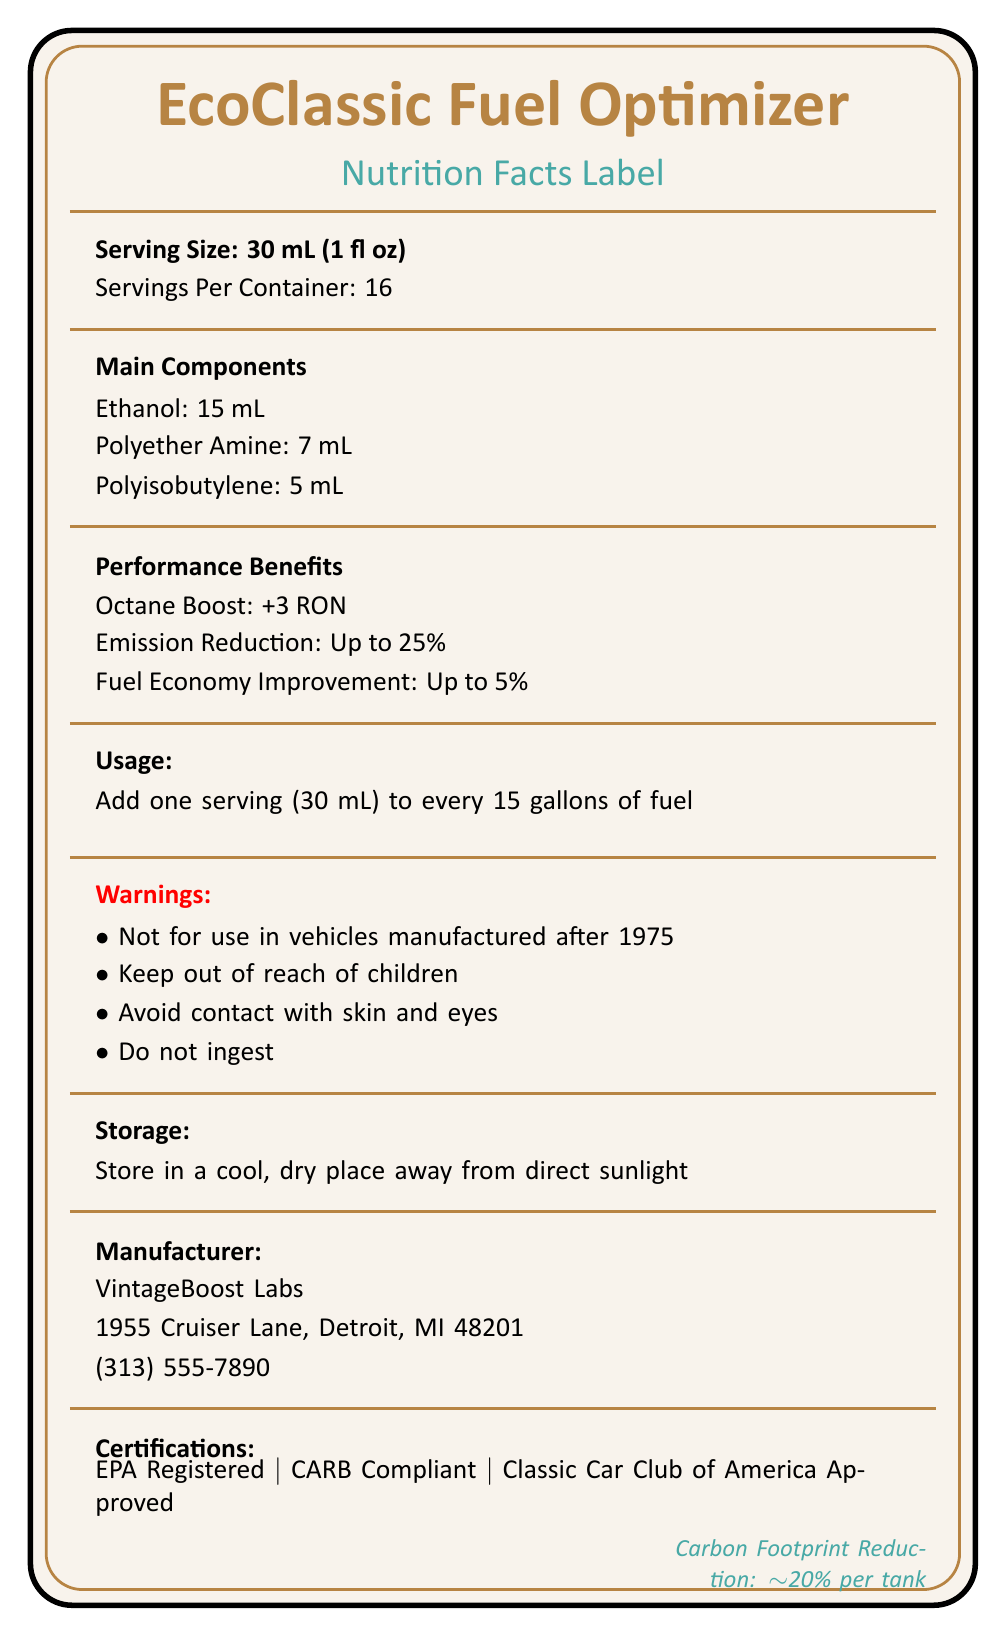what is the serving size of EcoClassic Fuel Optimizer? The serving size is clearly mentioned under the "Serving Size" section on the document.
Answer: 30 mL (1 fl oz) how many servings are there per container? The document states "Servings Per Container: 16".
Answer: 16 what are the primary ingredients of EcoClassic Fuel Optimizer? The primary ingredients are listed in the "Main Components" section of the document.
Answer: Ethanol, Polyether Amine, Polyisobutylene what is the recommended usage instruction for the product? The usage instructions are explicitly mentioned under the "Usage" section.
Answer: Add one serving (30 mL) to every 15 gallons of fuel where should EcoClassic Fuel Optimizer be stored? The storage instructions are mentioned under the "Storage" section.
Answer: In a cool, dry place away from direct sunlight which component is present in the largest amount? A. Polyisobutylene B. Polyether Amine C. Ethanol D. Detergent Additives Ethanol is present at 15 mL, Polyether Amine at 7 mL, and Polyisobutylene at 5 mL. The amount for detergent additives isn't provided.
Answer: C. Ethanol how much can this product improve fuel economy? A. Up to 5% B. Up to 25% C. Up to 15% D. Up to 10% The document states that fuel economy improvement is up to 5% under "Performance Benefits".
Answer: A. Up to 5% is EcoClassic Fuel Optimizer safe for use in vehicles manufactured after 1975? The warning section clearly states it is not for use in vehicles manufactured after 1975.
Answer: No does this fuel optimizer have any certifications? The certifications are listed as "EPA Registered", "CARB Compliant", and "Classic Car Club of America Approved".
Answer: Yes summarize the main purpose and benefits of EcoClassic Fuel Optimizer. This summary encapsulates the main features, benefits, and instructions mentioned in the document.
Answer: EcoClassic Fuel Optimizer is a fuel additive designed for classic cars with pre-1975 manufacture dates. It aims to improve octane levels by +3 RON, reduce emissions by up to 25%, and enhance fuel economy by up to 5%. The product contains ethanol, polyether amine, and polyisobutylene, among others. It must be added in 30 mL servings to every 15 gallons of fuel. The product is certified by EPA, CARB, and approved by the Classic Car Club of America. how much reduction can be expected in carbon footprint when using this product in per tank basis? The environmental impact section mentions a carbon footprint reduction by approximately 20% per tank.
Answer: Approximately 20% who manufactures EcoClassic Fuel Optimizer? The manufacturer's details are provided under the "Manufacturer" section.
Answer: VintageBoost Labs list one warning associated with the product usage. The "Warnings" section lists multiple points, and this is one of them.
Answer: Not for use in vehicles manufactured after 1975 can this product be ingested safely? One of the warnings clearly states "Do not ingest".
Answer: No name one type of classic car compatible with this fuel optimizer. The document lists compatible vehicles including "Pre-1975 American Muscle Cars".
Answer: Pre-1975 American Muscle Cars what is the phone number for the manufacturer of this product? The phone number is listed under the "Manufacturer" section.
Answer: (313) 555-7890 how can you determine the efficiency improvement attributed to the optimizer? The document does not provide detailed empirical data or studies demonstrating the specific efficiency improvements.
Answer: Not enough information 